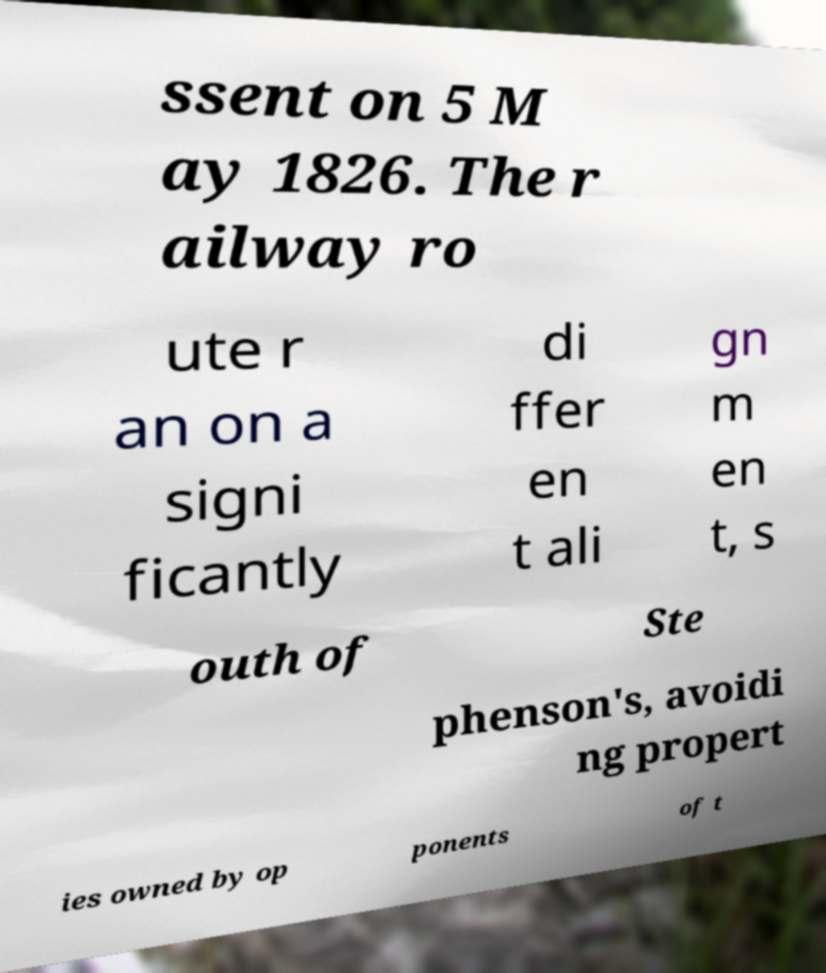Can you read and provide the text displayed in the image?This photo seems to have some interesting text. Can you extract and type it out for me? ssent on 5 M ay 1826. The r ailway ro ute r an on a signi ficantly di ffer en t ali gn m en t, s outh of Ste phenson's, avoidi ng propert ies owned by op ponents of t 